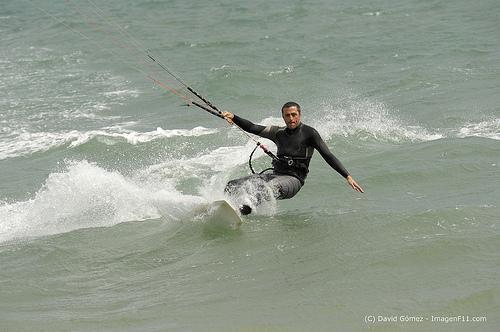How many people are in the picture?
Give a very brief answer. 1. 